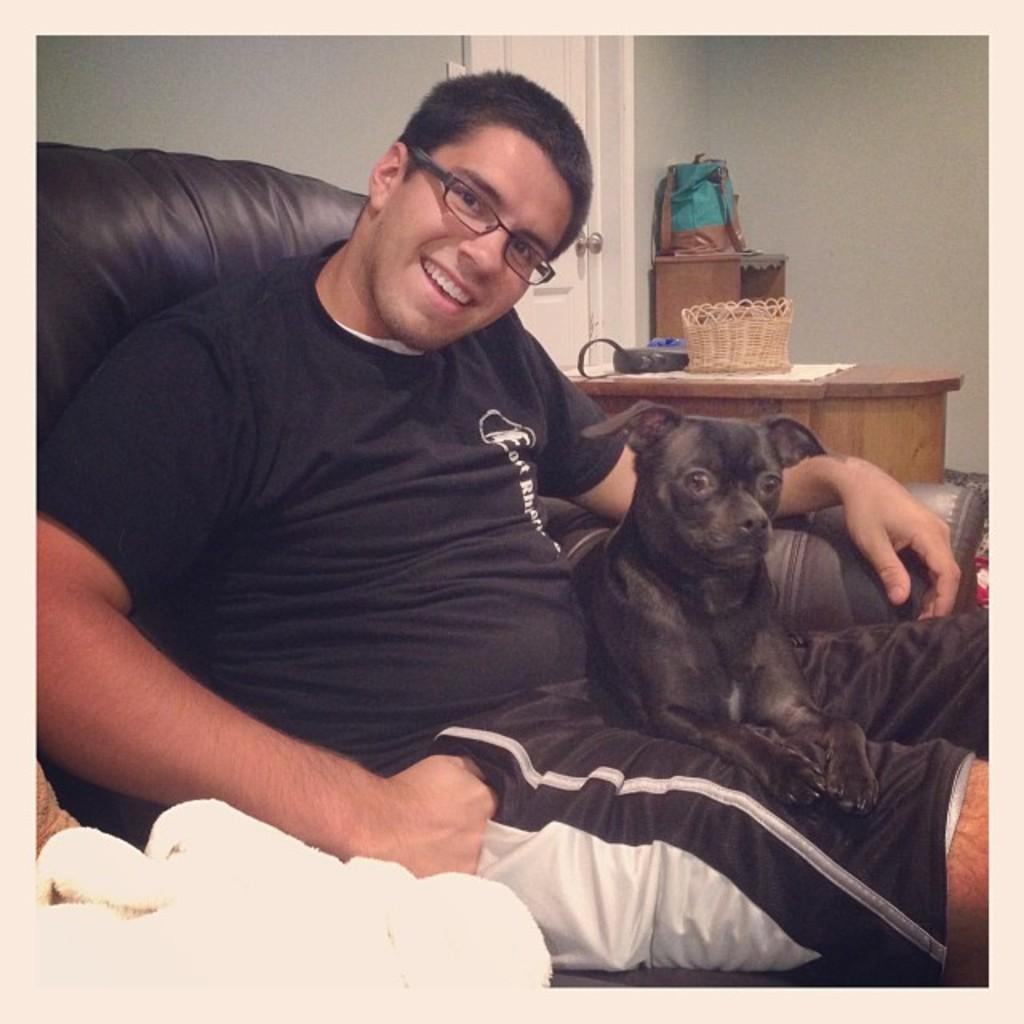What is the man in the image doing? The man is sitting on the sofa. What is on the man's lap? A dog is sitting on the man's lap. What object can be seen on the table? There is a basket on the table. What color is the cloth mentioned in the image? The cloth is white-colored. What type of pancake is being prepared on the sofa? There is no pancake present in the image, and the man is not preparing any food. 